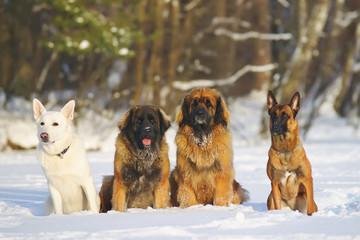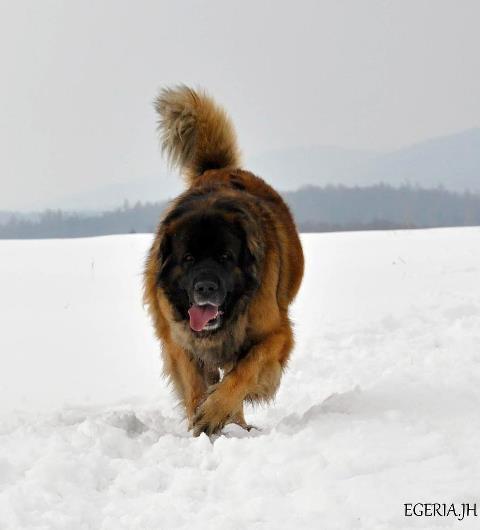The first image is the image on the left, the second image is the image on the right. For the images shown, is this caption "There are at most two dogs." true? Answer yes or no. No. The first image is the image on the left, the second image is the image on the right. For the images displayed, is the sentence "There are a total of exactly two dogs." factually correct? Answer yes or no. No. 